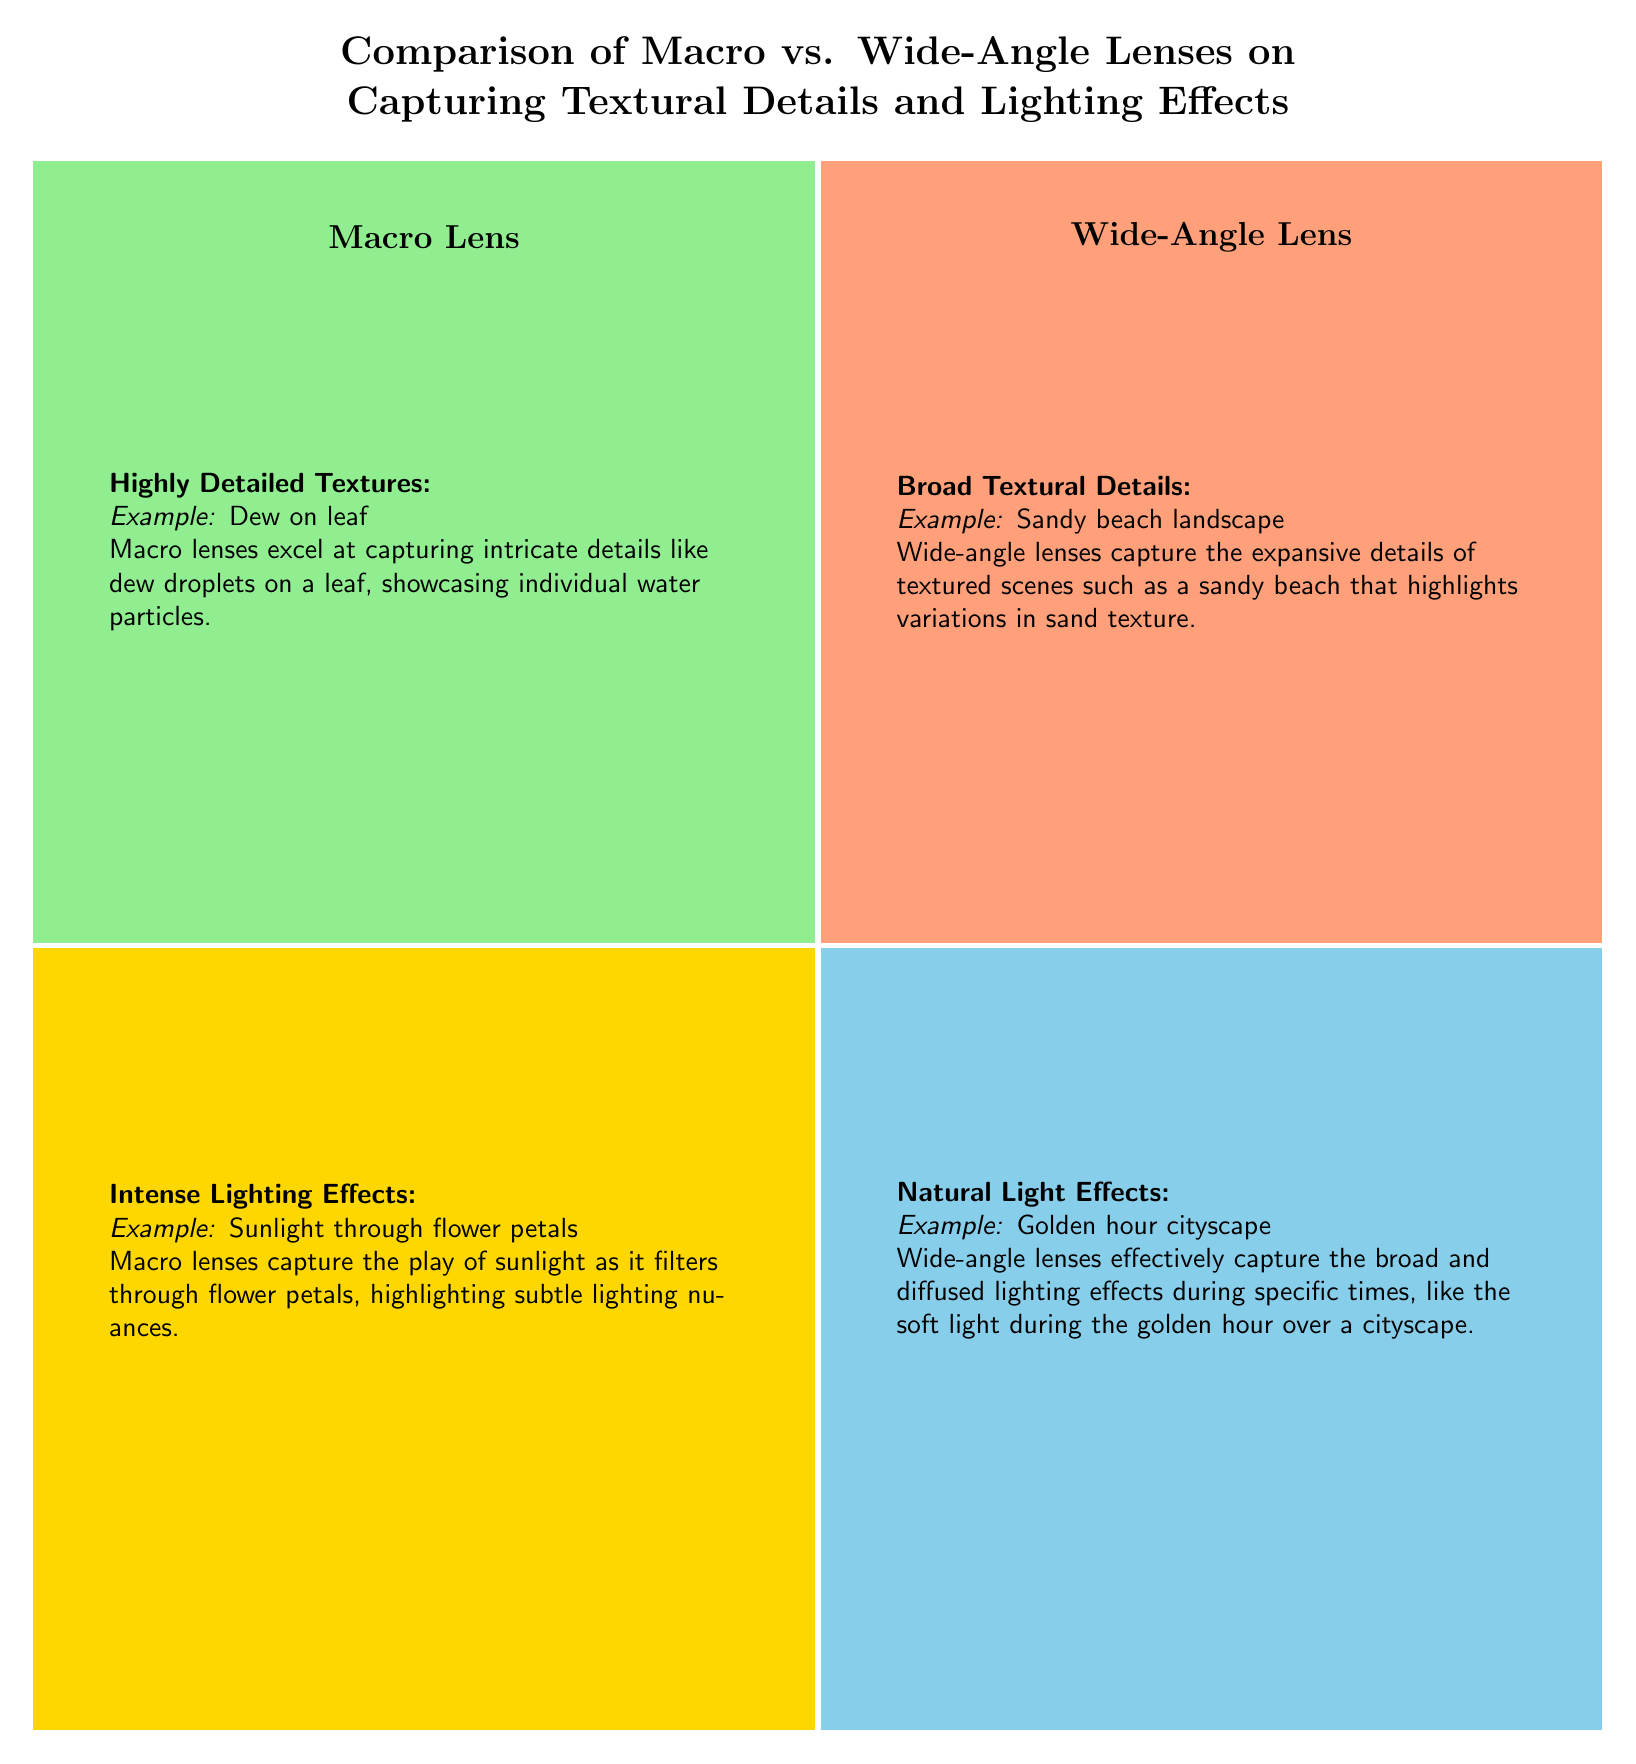What are the examples provided for macro lenses? The diagram lists two examples for macro lenses: "dew on leaf" and "sunlight through flower petals", indicating the specific textural detail and lighting effect achieved with macro lenses.
Answer: dew on leaf, sunlight through flower petals What is captured by wide-angle lenses according to the diagram? The diagram specifies "sandy beach landscape" and "golden hour cityscape" as examples of how wide-angle lenses capture broad textural details and natural light effects.
Answer: sandy beach landscape, golden hour cityscape How many quadrants are there in the chart? The diagram shows four clearly defined quadrants, each representing different aspects of macro and wide-angle lenses regarding textures and lighting.
Answer: 4 Which lens excels at capturing intricate details? The information in the quadrant for macro lenses highlights that they excel at capturing intricate details, specifically through the example given in the "Highly Detailed Textures" section about dew on a leaf.
Answer: Macro Lens What type of lighting effect is captured during the golden hour? The diagram mentions that wide-angle lenses effectively capture broad and diffused lighting effects during specific times like the golden hour, especially illustrated with the example of a cityscape.
Answer: Natural light effects What does the macro lens demonstrate in the context of intense lighting effects? According to the diagram, the macro lens demonstrates capturing the nuances of intense lighting effects evidenced by the sunlight filtering through flower petals.
Answer: Sunlight through flower petals Which type of lens is suggested for expansive details of textured scenes? The diagram indicates that wide-angle lenses are suggested for capturing expansive details of textured scenes, as described in the "Broad Textural Details" section with the example given of a sandy beach.
Answer: Wide-Angle Lens What does the macro lens excel at when it comes to textures? The diagram specifies that the macro lens excels at capturing highly detailed textures, which is represented by the example of dew on a leaf.
Answer: Highly Detailed Textures 